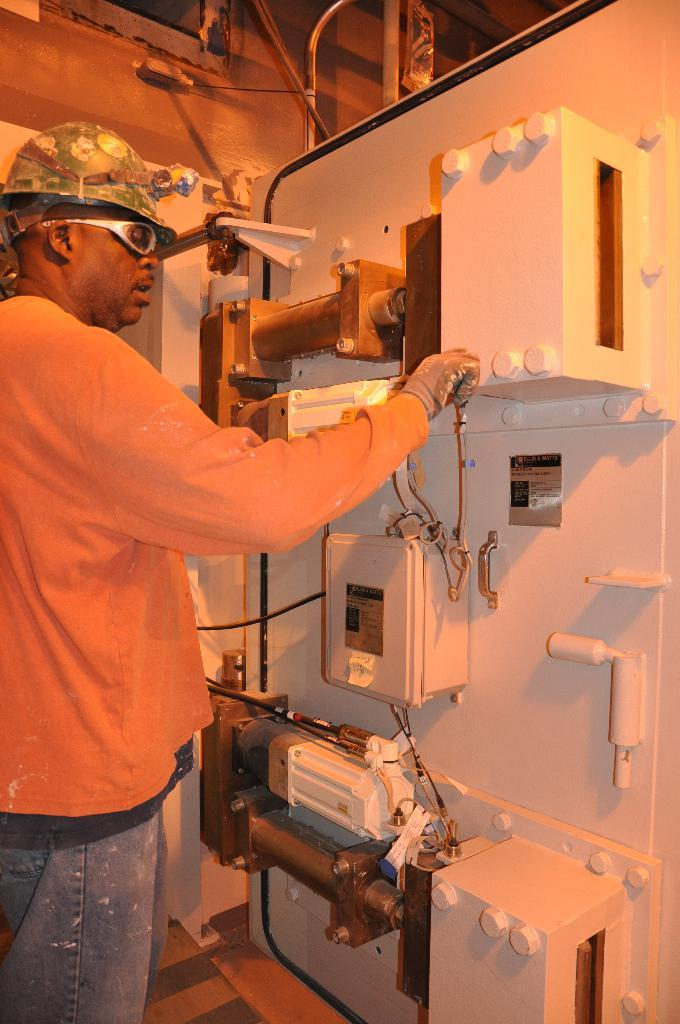Who is present in the image? There is a man in the image. What is the man wearing on his face? The man is wearing goggles. What type of headwear is the man wearing? The man is wearing a cap. What can be seen on the right side of the image? There are electrical devices on the right side of the image. What is the rate of the sofa in the image? There is no sofa present in the image, so it is not possible to determine a rate. 